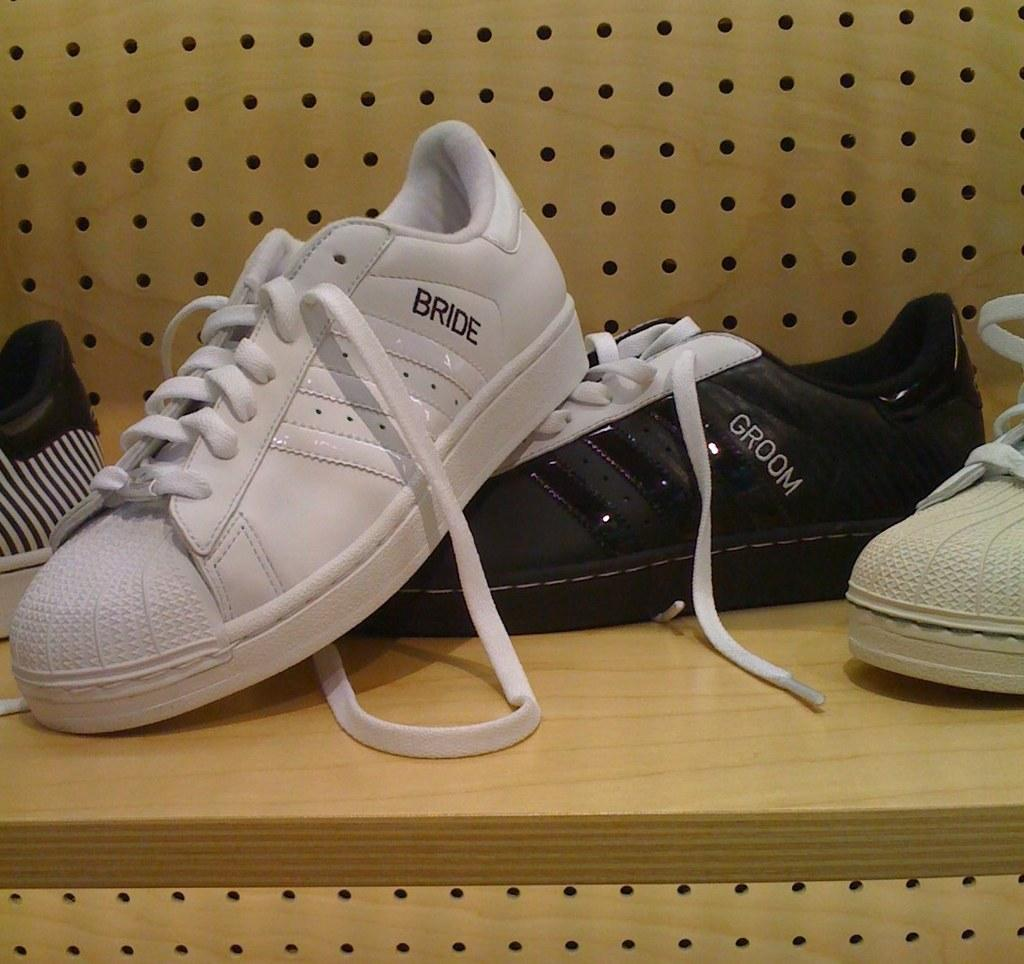What type of furniture is in the image? There is a cream-colored desk in the image. What is placed on the desk? There are shoes on the desk. Can you describe the shoes on the desk? The shoes are white, black, and cream in color. What can be seen in the background of the image? There is a cream-colored surface visible in the background of the image. What type of voyage is depicted in the image? There is no voyage depicted in the image; it features a desk with shoes on it. Can you tell me how many spades are used in the image? There are no spades present in the image. 